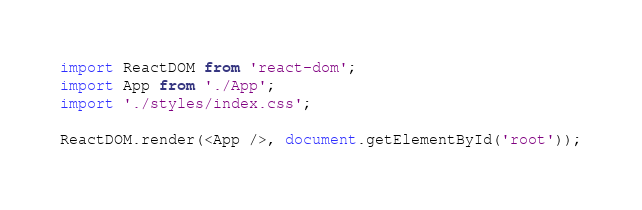Convert code to text. <code><loc_0><loc_0><loc_500><loc_500><_TypeScript_>import ReactDOM from 'react-dom';
import App from './App';
import './styles/index.css';

ReactDOM.render(<App />, document.getElementById('root'));
</code> 